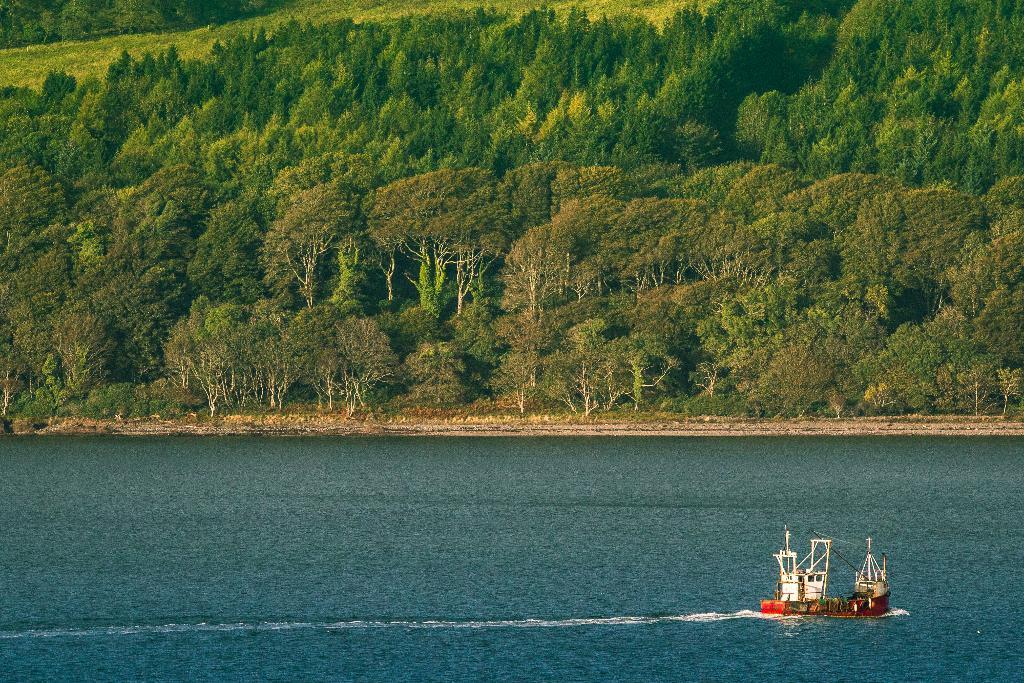Can you describe this image briefly? In this image I can see the boat on the water. I can see the water in blue color. In the background I can see many trees. 